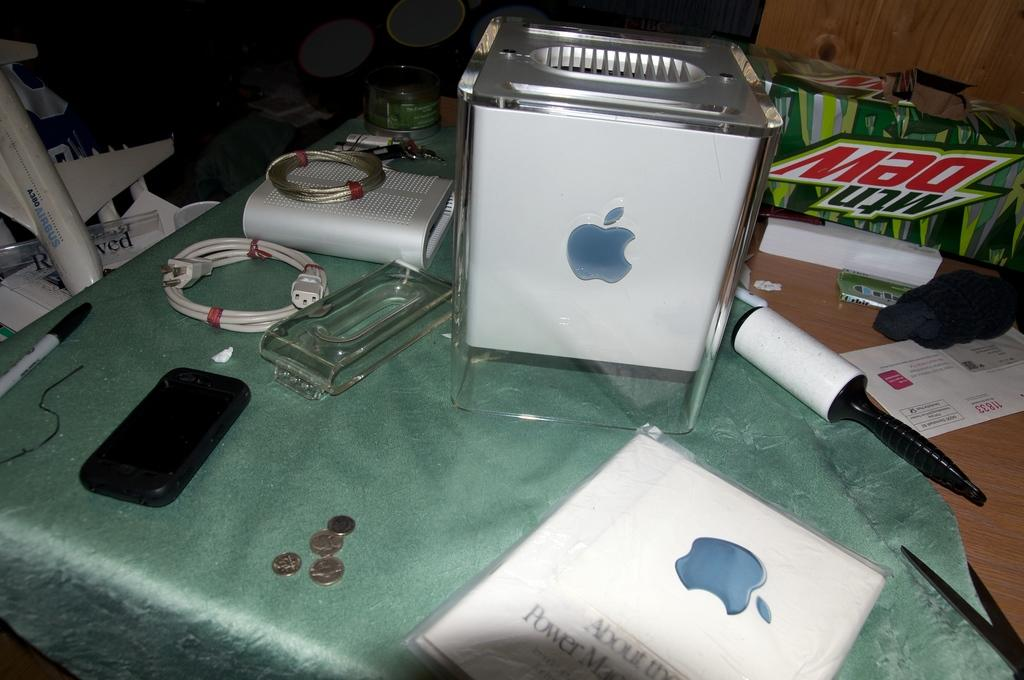<image>
Render a clear and concise summary of the photo. an apple computer on the table with an empty mtn dew box 